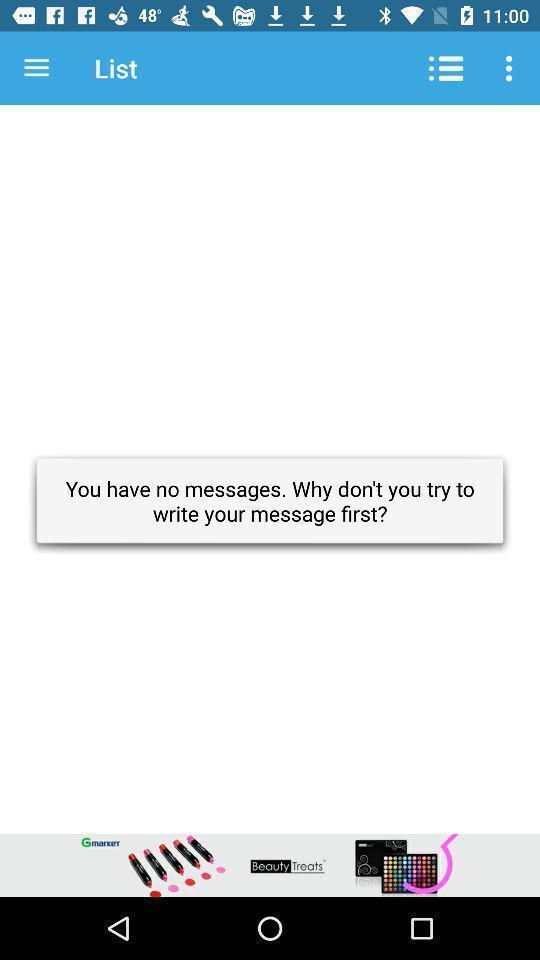Summarize the information in this screenshot. Pop up displayed with no messages. 